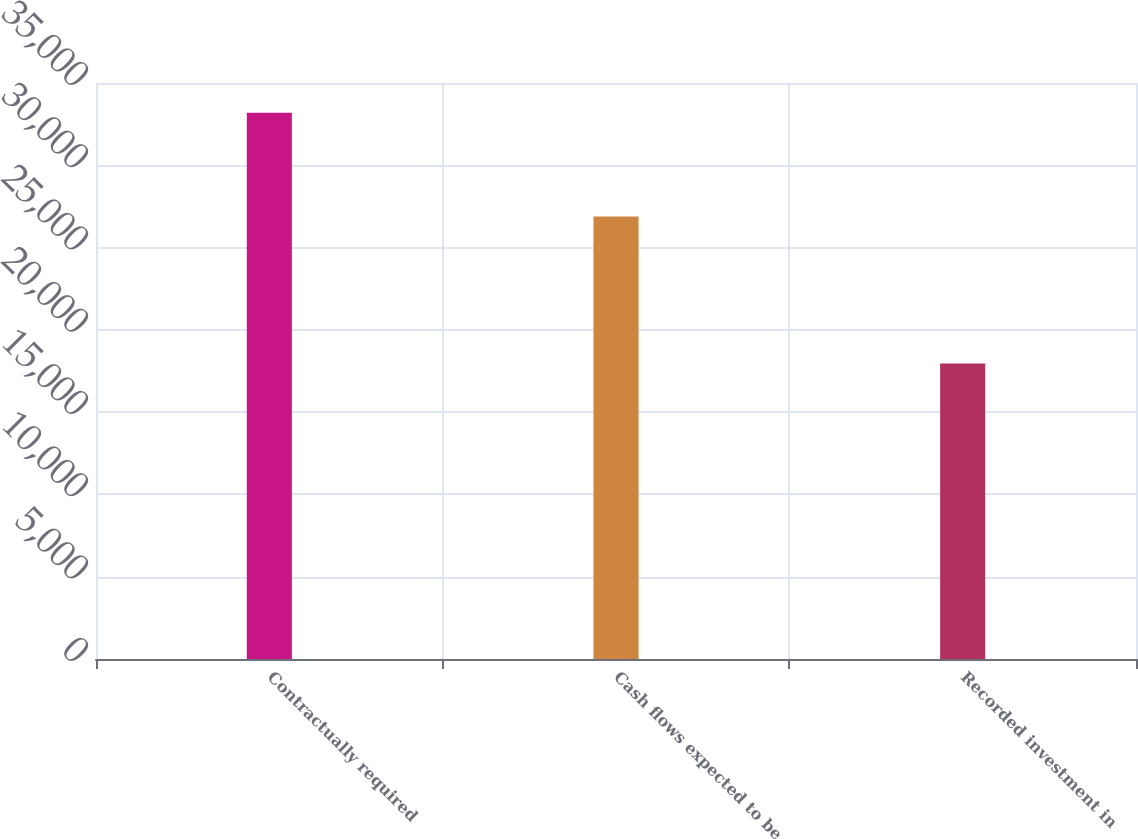Convert chart. <chart><loc_0><loc_0><loc_500><loc_500><bar_chart><fcel>Contractually required<fcel>Cash flows expected to be<fcel>Recorded investment in<nl><fcel>33191<fcel>26882<fcel>17955<nl></chart> 